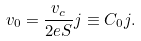Convert formula to latex. <formula><loc_0><loc_0><loc_500><loc_500>v _ { 0 } = \frac { v _ { c } } { 2 e S } j \equiv C _ { 0 } j .</formula> 